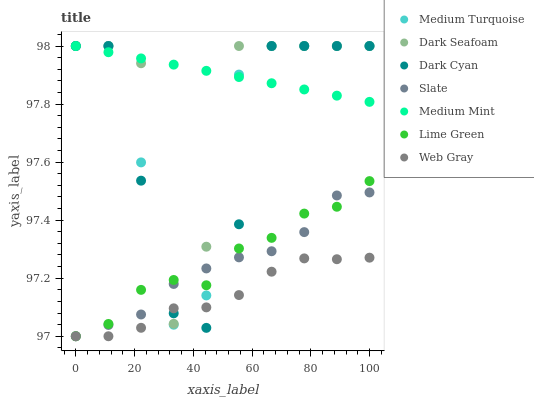Does Web Gray have the minimum area under the curve?
Answer yes or no. Yes. Does Medium Mint have the maximum area under the curve?
Answer yes or no. Yes. Does Slate have the minimum area under the curve?
Answer yes or no. No. Does Slate have the maximum area under the curve?
Answer yes or no. No. Is Medium Mint the smoothest?
Answer yes or no. Yes. Is Dark Seafoam the roughest?
Answer yes or no. Yes. Is Web Gray the smoothest?
Answer yes or no. No. Is Web Gray the roughest?
Answer yes or no. No. Does Web Gray have the lowest value?
Answer yes or no. Yes. Does Dark Seafoam have the lowest value?
Answer yes or no. No. Does Dark Cyan have the highest value?
Answer yes or no. Yes. Does Slate have the highest value?
Answer yes or no. No. Is Lime Green less than Medium Mint?
Answer yes or no. Yes. Is Medium Mint greater than Lime Green?
Answer yes or no. Yes. Does Medium Turquoise intersect Dark Cyan?
Answer yes or no. Yes. Is Medium Turquoise less than Dark Cyan?
Answer yes or no. No. Is Medium Turquoise greater than Dark Cyan?
Answer yes or no. No. Does Lime Green intersect Medium Mint?
Answer yes or no. No. 